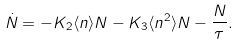Convert formula to latex. <formula><loc_0><loc_0><loc_500><loc_500>\dot { N } = - K _ { 2 } \langle n \rangle N - K _ { 3 } \langle n ^ { 2 } \rangle N - \frac { N } { \tau } .</formula> 